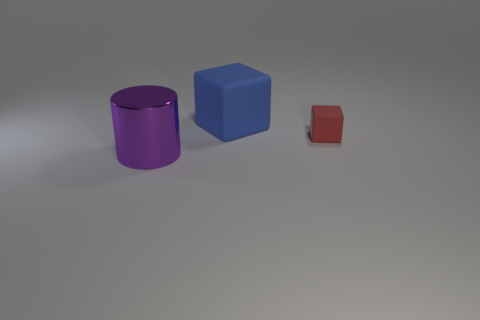Add 3 big blue rubber things. How many objects exist? 6 Subtract all cylinders. How many objects are left? 2 Subtract 0 purple balls. How many objects are left? 3 Subtract all green cylinders. Subtract all purple cubes. How many cylinders are left? 1 Subtract all tiny red matte blocks. Subtract all small gray metal things. How many objects are left? 2 Add 2 small things. How many small things are left? 3 Add 1 small red blocks. How many small red blocks exist? 2 